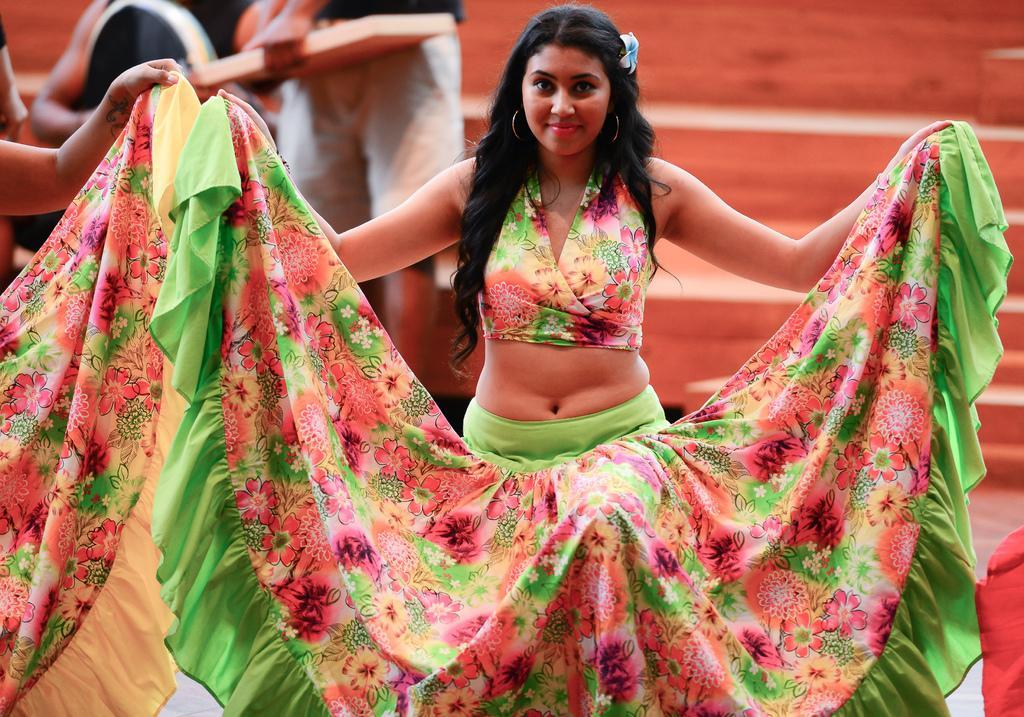How would you summarize this image in a sentence or two? In the background we can see stairs and people. We can see a woman standing and her hair is long in black color. She is holding her skirt with hands and smiling. 